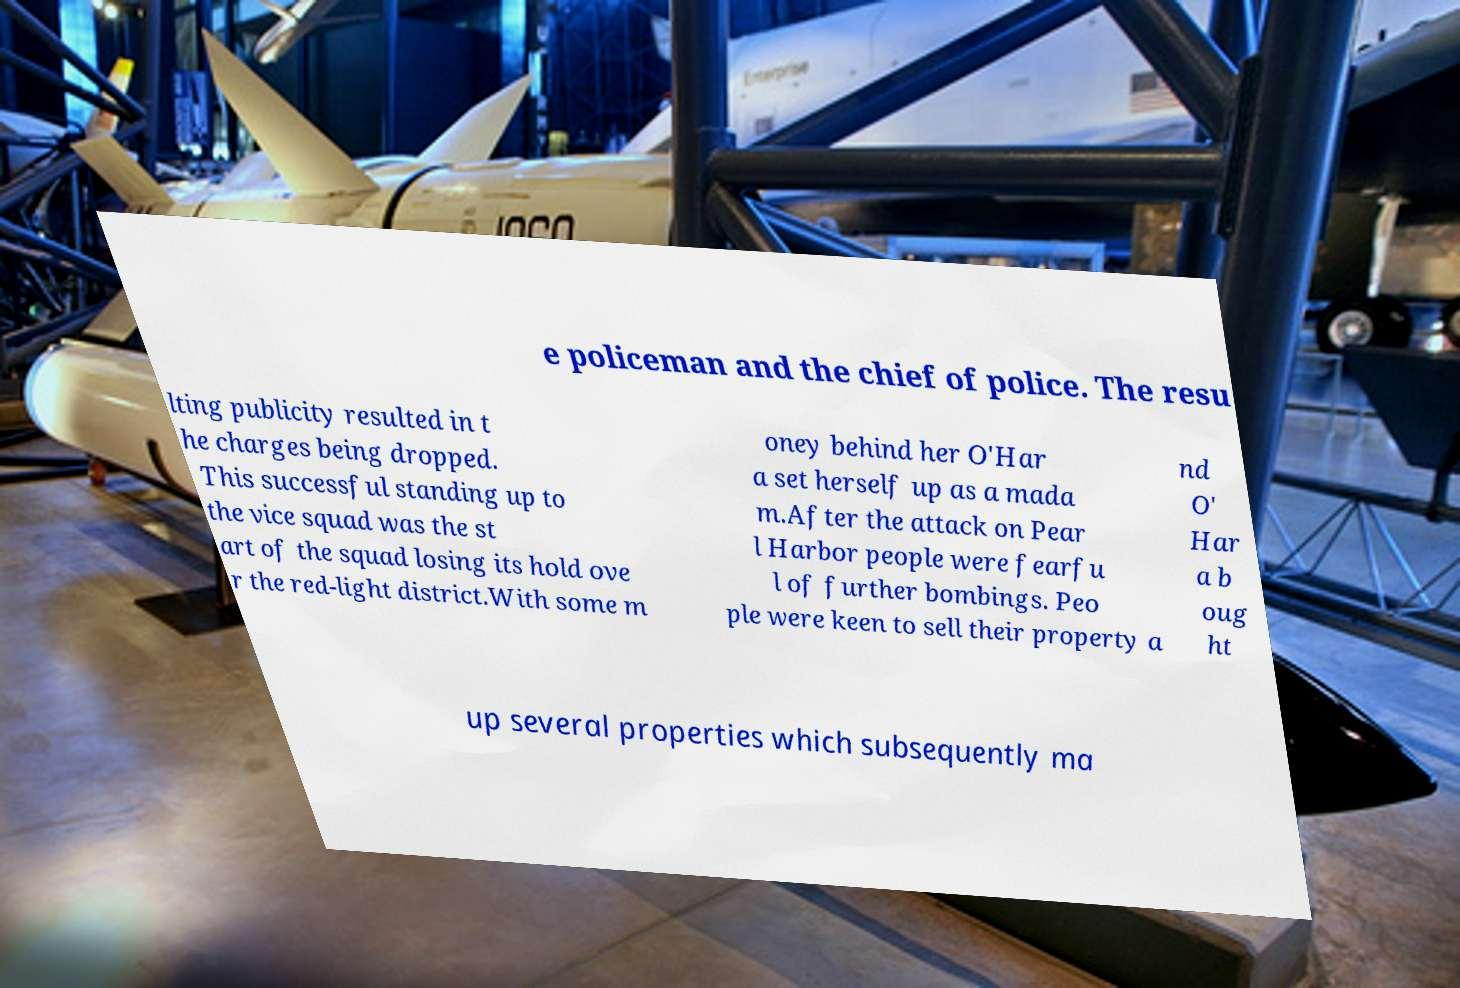What messages or text are displayed in this image? I need them in a readable, typed format. e policeman and the chief of police. The resu lting publicity resulted in t he charges being dropped. This successful standing up to the vice squad was the st art of the squad losing its hold ove r the red-light district.With some m oney behind her O'Har a set herself up as a mada m.After the attack on Pear l Harbor people were fearfu l of further bombings. Peo ple were keen to sell their property a nd O' Har a b oug ht up several properties which subsequently ma 